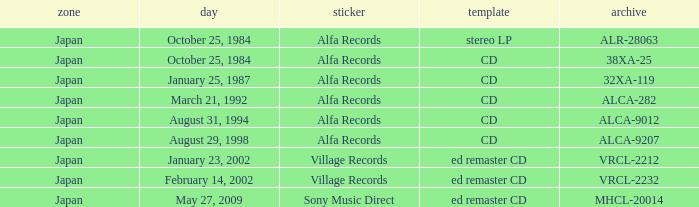What are the catalogs of releases from Sony Music Direct? MHCL-20014. 